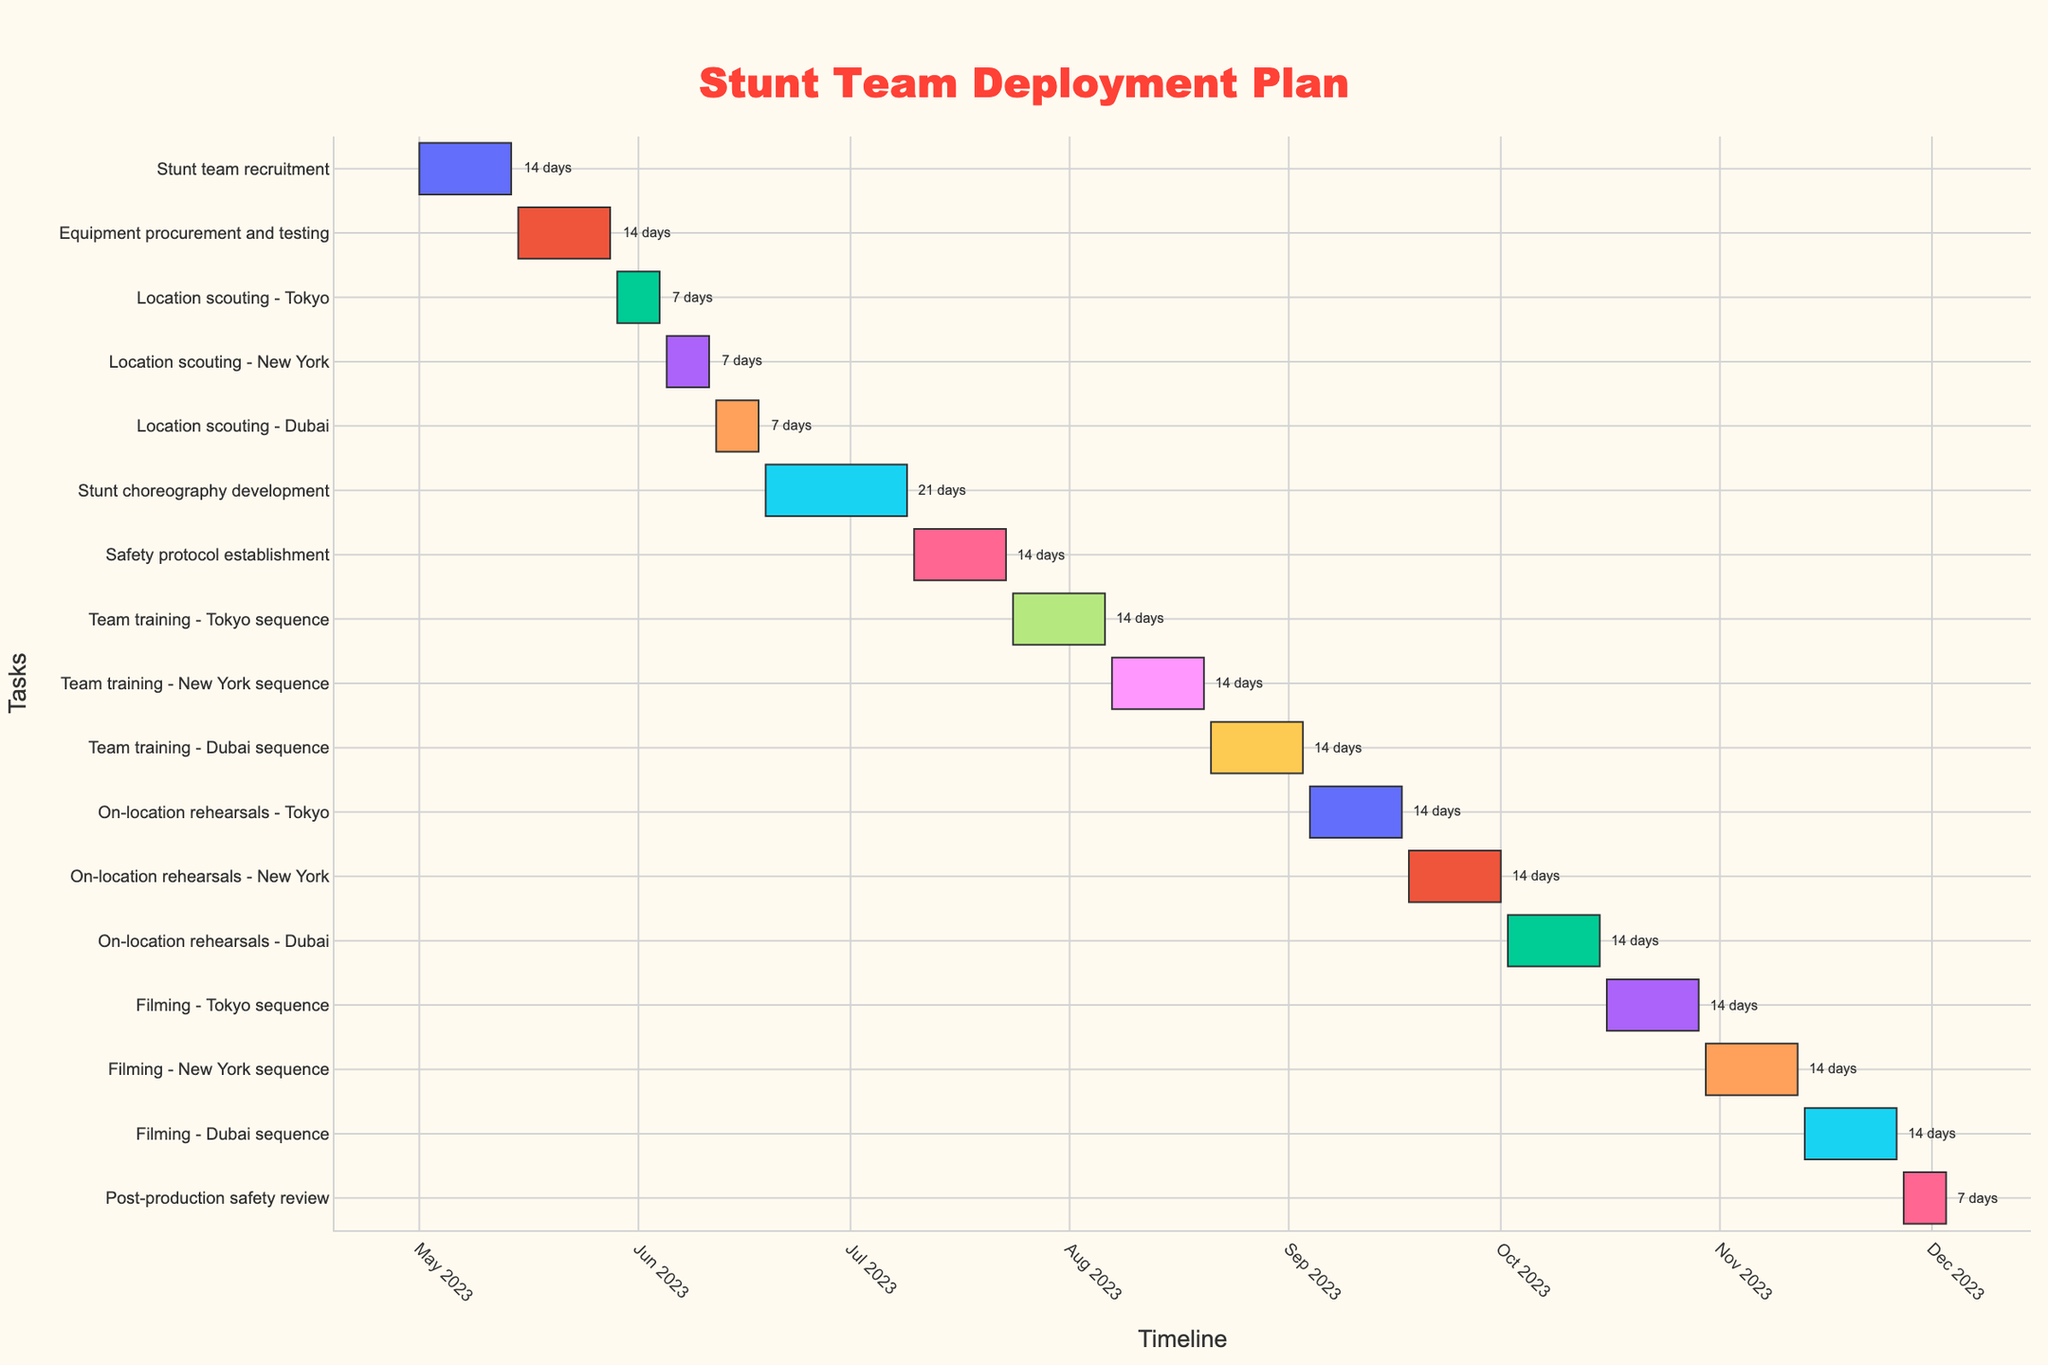what is the duration of the Equipment procurement and testing task? Identify the task "Equipment procurement and testing" in the Gantt chart. Look at the duration label next to the corresponding bar in the figure. The label indicates the duration of the task.
Answer: 14 days What task starts immediately after 'Location scouting - New York'? Find the end date of 'Location scouting - New York' in the Gantt chart and identify the subsequent task that starts on the next day or immediately after.
Answer: Location scouting - Dubai Which task has the shortest duration? Compare the duration labels for all tasks in the Gantt chart. Identify the task with the smallest number of days.
Answer: Post-production safety review How much time will be spent on on-location rehearsals across all locations? Identify the duration of on-location rehearsals for Tokyo, New York, and Dubai from their respective bars. Sum the durations of these three tasks (14 + 14 + 14).
Answer: 42 days When does the 'Filming - Dubai sequence' end? Find the task "Filming - Dubai sequence" in the Gantt chart. Note the end date displayed next to the corresponding bar in the figure.
Answer: 2023-11-26 Which task spans the longest duration? Compare the duration labels for all tasks in the Gantt chart. Identify the task with the largest number of days.
Answer: Stunt choreography development How many tasks are there between 'Location scouting - New York' and 'Team training - Tokyo sequence' inclusively? Count the number of bars/tasks starting from 'Location scouting - New York' to 'Team training - Tokyo sequence'.
Answer: 3 What is the total duration from 'Stunt team recruitment' to 'Equipment procurement and testing'? Find the start date of 'Stunt team recruitment' and the end date of 'Equipment procurement and testing'. Calculate the number of days between these two dates. The duration from 2023-05-01 to 2023-05-28 is 28 days in total.
Answer: 28 days How many tasks take place before 'Stunt choreography development' begins? Count the number of bars/tasks starting and ending before the start date of 'Stunt choreography development'.
Answer: 5 When does the 'Safety protocol establishment' task occur in relation to 'Stunt team recruitment'? Look at the start and end dates of both tasks in the Gantt chart. 'Safety protocol establishment' starts after 'Stunt team recruitment' ends.
Answer: After 